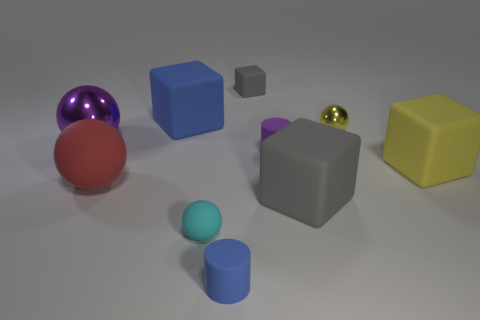There is a small sphere that is to the right of the cylinder behind the large red ball that is in front of the yellow block; what is its color?
Your answer should be compact. Yellow. Is the number of blue cylinders behind the small cyan sphere less than the number of balls that are in front of the big red rubber ball?
Your answer should be very brief. Yes. Do the purple metal thing and the red rubber thing have the same shape?
Your answer should be very brief. Yes. What number of other matte balls are the same size as the cyan ball?
Offer a terse response. 0. Are there fewer tiny cyan rubber things that are to the right of the yellow metal object than big purple rubber blocks?
Offer a terse response. No. What size is the metal ball that is left of the gray matte object that is in front of the red sphere?
Give a very brief answer. Large. What number of things are big rubber things or rubber cylinders?
Make the answer very short. 6. Is there a large block that has the same color as the small cube?
Your answer should be very brief. Yes. Are there fewer purple cylinders than large green matte blocks?
Your response must be concise. No. What number of objects are either tiny purple rubber things or gray rubber objects right of the tiny rubber cube?
Provide a short and direct response. 2. 